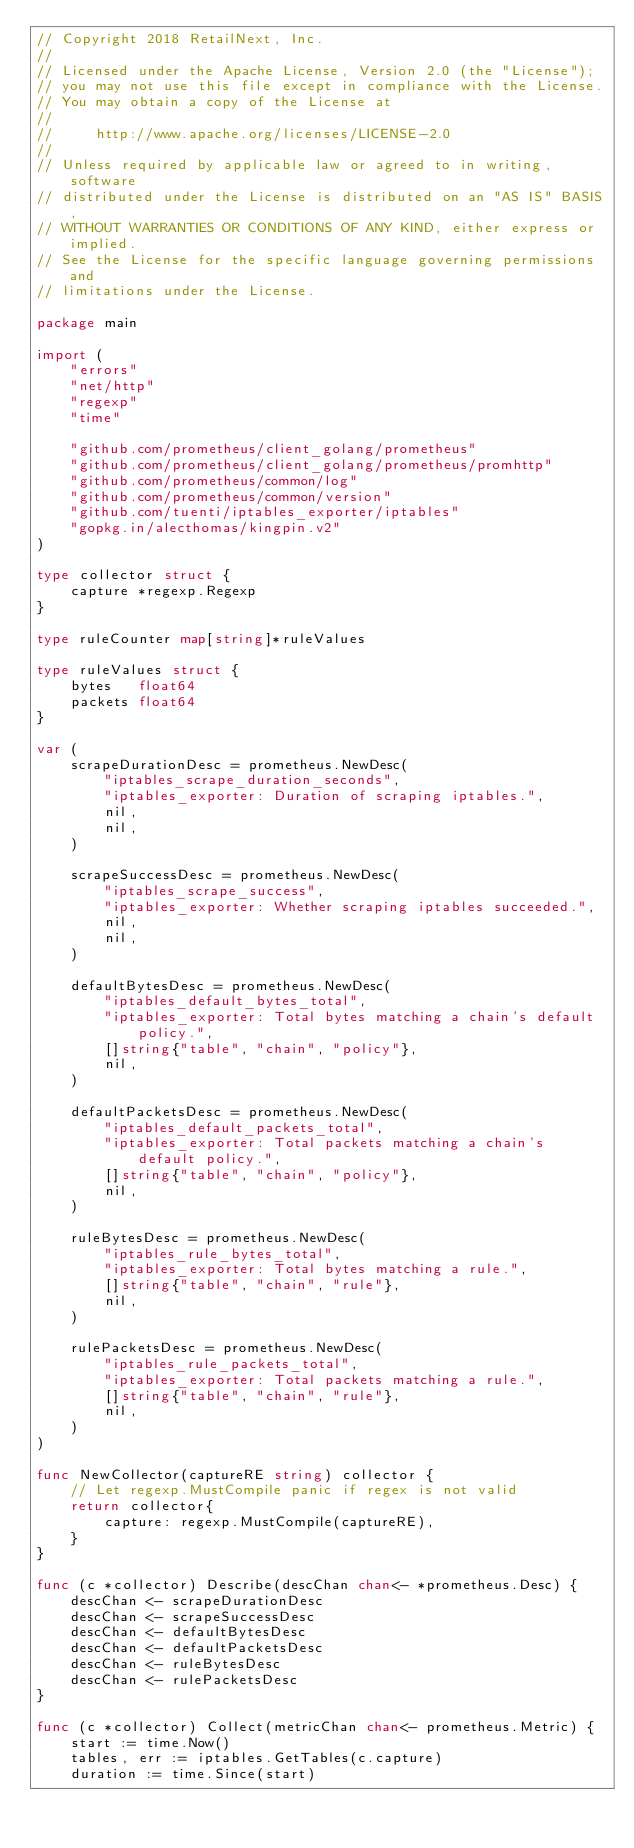<code> <loc_0><loc_0><loc_500><loc_500><_Go_>// Copyright 2018 RetailNext, Inc.
//
// Licensed under the Apache License, Version 2.0 (the "License");
// you may not use this file except in compliance with the License.
// You may obtain a copy of the License at
//
//     http://www.apache.org/licenses/LICENSE-2.0
//
// Unless required by applicable law or agreed to in writing, software
// distributed under the License is distributed on an "AS IS" BASIS,
// WITHOUT WARRANTIES OR CONDITIONS OF ANY KIND, either express or implied.
// See the License for the specific language governing permissions and
// limitations under the License.

package main

import (
	"errors"
	"net/http"
	"regexp"
	"time"

	"github.com/prometheus/client_golang/prometheus"
	"github.com/prometheus/client_golang/prometheus/promhttp"
	"github.com/prometheus/common/log"
	"github.com/prometheus/common/version"
	"github.com/tuenti/iptables_exporter/iptables"
	"gopkg.in/alecthomas/kingpin.v2"
)

type collector struct {
	capture *regexp.Regexp
}

type ruleCounter map[string]*ruleValues

type ruleValues struct {
	bytes   float64
	packets float64
}

var (
	scrapeDurationDesc = prometheus.NewDesc(
		"iptables_scrape_duration_seconds",
		"iptables_exporter: Duration of scraping iptables.",
		nil,
		nil,
	)

	scrapeSuccessDesc = prometheus.NewDesc(
		"iptables_scrape_success",
		"iptables_exporter: Whether scraping iptables succeeded.",
		nil,
		nil,
	)

	defaultBytesDesc = prometheus.NewDesc(
		"iptables_default_bytes_total",
		"iptables_exporter: Total bytes matching a chain's default policy.",
		[]string{"table", "chain", "policy"},
		nil,
	)

	defaultPacketsDesc = prometheus.NewDesc(
		"iptables_default_packets_total",
		"iptables_exporter: Total packets matching a chain's default policy.",
		[]string{"table", "chain", "policy"},
		nil,
	)

	ruleBytesDesc = prometheus.NewDesc(
		"iptables_rule_bytes_total",
		"iptables_exporter: Total bytes matching a rule.",
		[]string{"table", "chain", "rule"},
		nil,
	)

	rulePacketsDesc = prometheus.NewDesc(
		"iptables_rule_packets_total",
		"iptables_exporter: Total packets matching a rule.",
		[]string{"table", "chain", "rule"},
		nil,
	)
)

func NewCollector(captureRE string) collector {
	// Let regexp.MustCompile panic if regex is not valid
	return collector{
		capture: regexp.MustCompile(captureRE),
	}
}

func (c *collector) Describe(descChan chan<- *prometheus.Desc) {
	descChan <- scrapeDurationDesc
	descChan <- scrapeSuccessDesc
	descChan <- defaultBytesDesc
	descChan <- defaultPacketsDesc
	descChan <- ruleBytesDesc
	descChan <- rulePacketsDesc
}

func (c *collector) Collect(metricChan chan<- prometheus.Metric) {
	start := time.Now()
	tables, err := iptables.GetTables(c.capture)
	duration := time.Since(start)</code> 